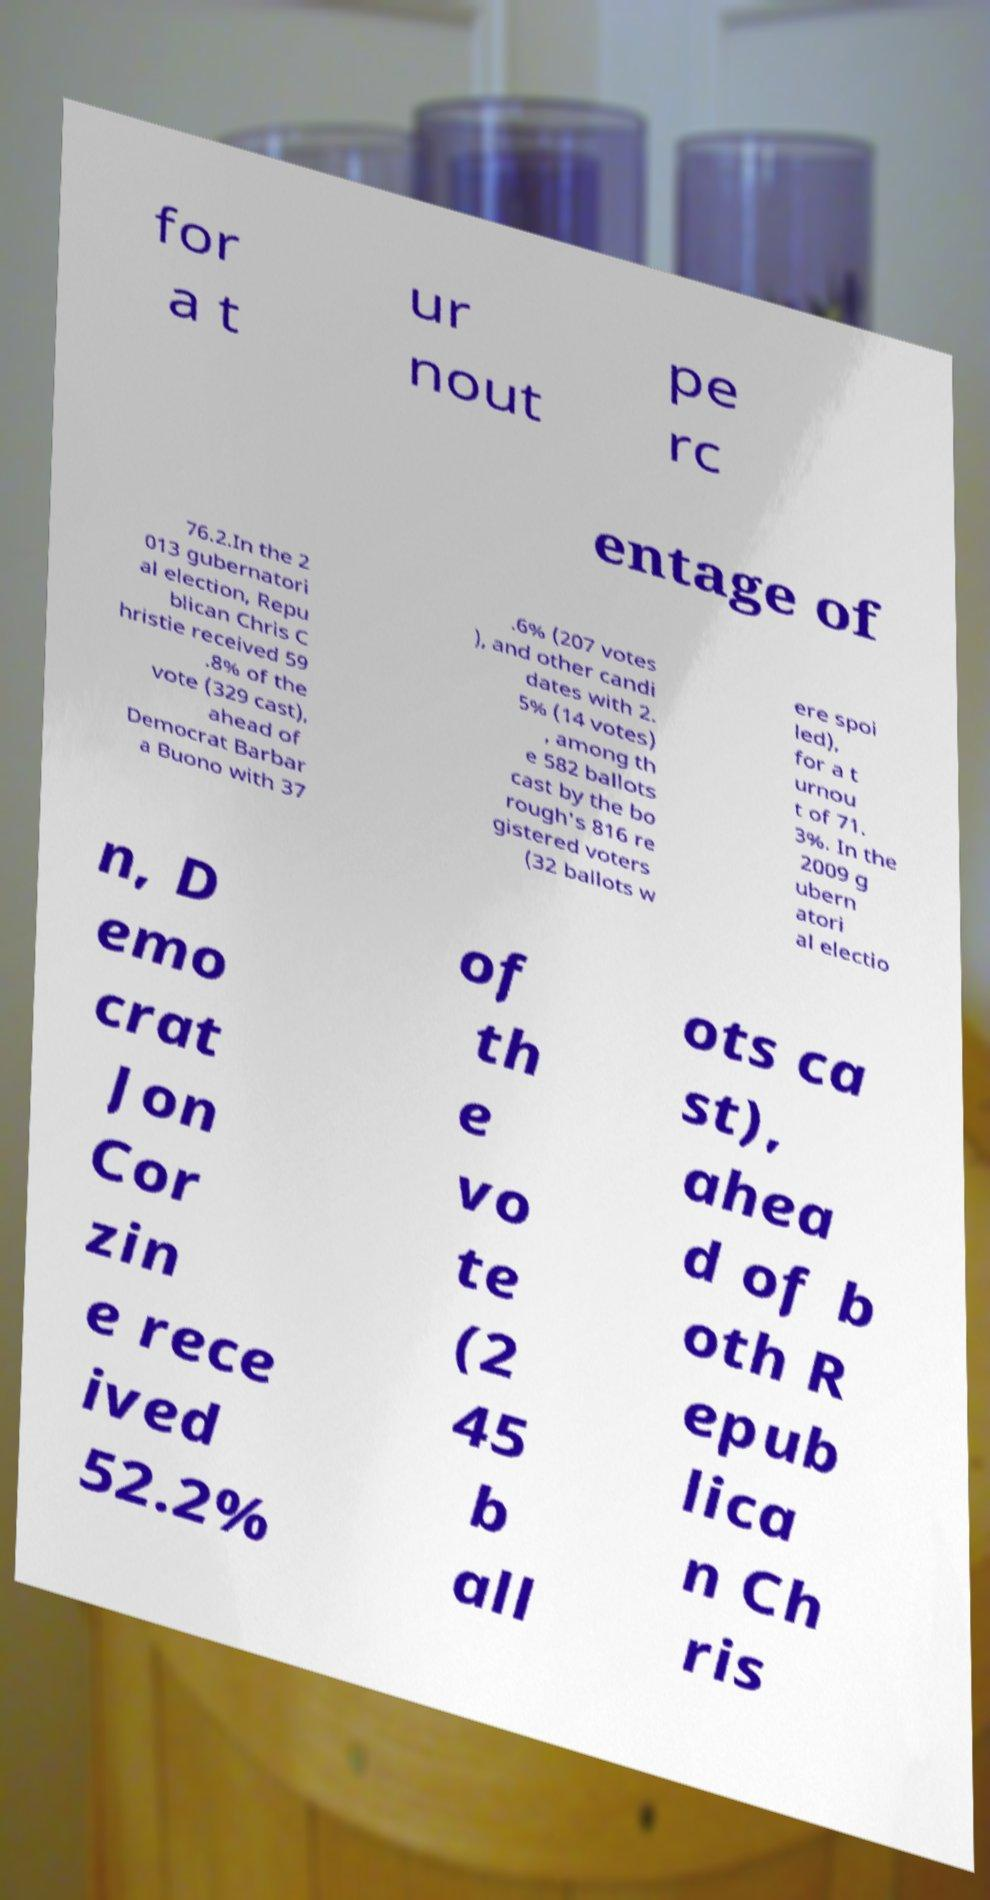I need the written content from this picture converted into text. Can you do that? for a t ur nout pe rc entage of 76.2.In the 2 013 gubernatori al election, Repu blican Chris C hristie received 59 .8% of the vote (329 cast), ahead of Democrat Barbar a Buono with 37 .6% (207 votes ), and other candi dates with 2. 5% (14 votes) , among th e 582 ballots cast by the bo rough's 816 re gistered voters (32 ballots w ere spoi led), for a t urnou t of 71. 3%. In the 2009 g ubern atori al electio n, D emo crat Jon Cor zin e rece ived 52.2% of th e vo te (2 45 b all ots ca st), ahea d of b oth R epub lica n Ch ris 